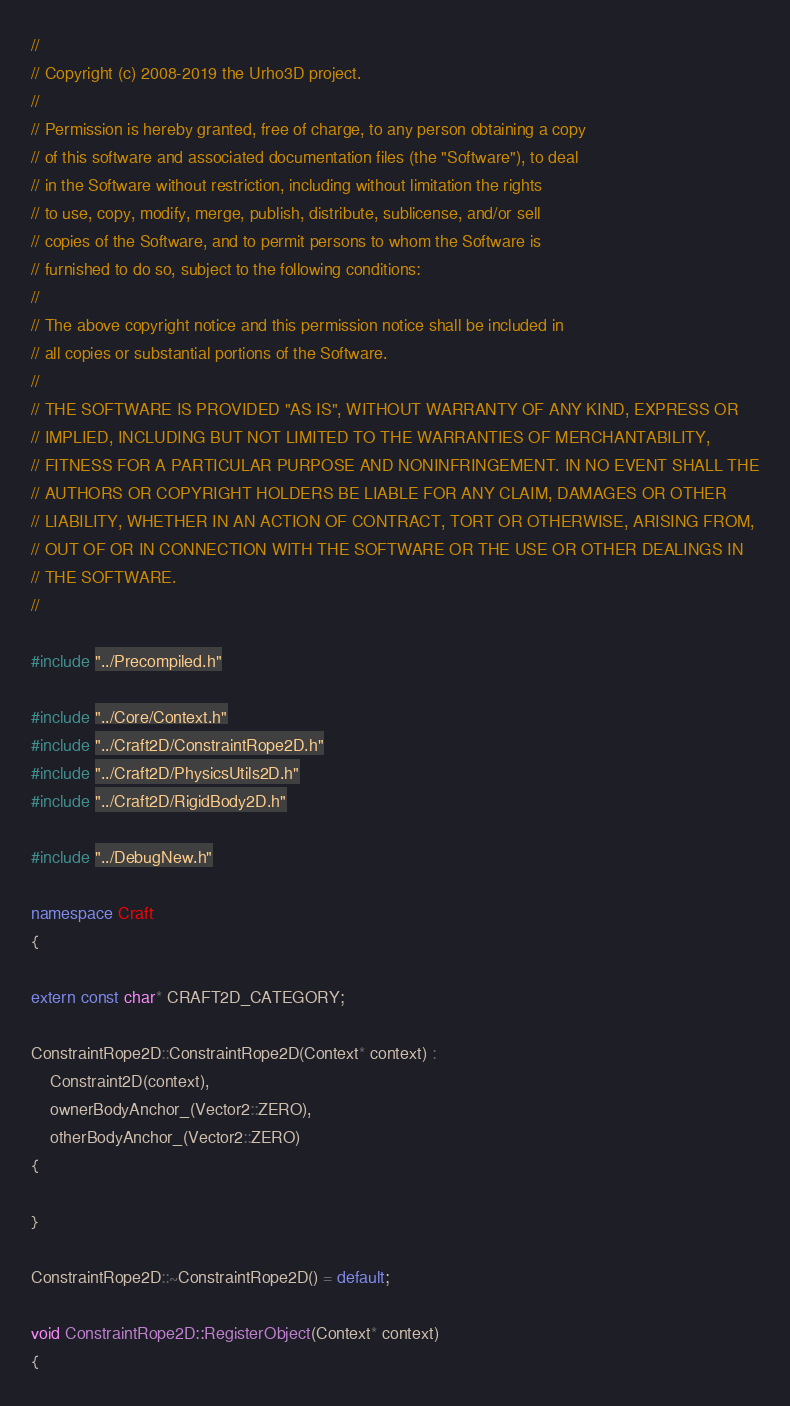<code> <loc_0><loc_0><loc_500><loc_500><_C++_>//
// Copyright (c) 2008-2019 the Urho3D project.
//
// Permission is hereby granted, free of charge, to any person obtaining a copy
// of this software and associated documentation files (the "Software"), to deal
// in the Software without restriction, including without limitation the rights
// to use, copy, modify, merge, publish, distribute, sublicense, and/or sell
// copies of the Software, and to permit persons to whom the Software is
// furnished to do so, subject to the following conditions:
//
// The above copyright notice and this permission notice shall be included in
// all copies or substantial portions of the Software.
//
// THE SOFTWARE IS PROVIDED "AS IS", WITHOUT WARRANTY OF ANY KIND, EXPRESS OR
// IMPLIED, INCLUDING BUT NOT LIMITED TO THE WARRANTIES OF MERCHANTABILITY,
// FITNESS FOR A PARTICULAR PURPOSE AND NONINFRINGEMENT. IN NO EVENT SHALL THE
// AUTHORS OR COPYRIGHT HOLDERS BE LIABLE FOR ANY CLAIM, DAMAGES OR OTHER
// LIABILITY, WHETHER IN AN ACTION OF CONTRACT, TORT OR OTHERWISE, ARISING FROM,
// OUT OF OR IN CONNECTION WITH THE SOFTWARE OR THE USE OR OTHER DEALINGS IN
// THE SOFTWARE.
//

#include "../Precompiled.h"

#include "../Core/Context.h"
#include "../Craft2D/ConstraintRope2D.h"
#include "../Craft2D/PhysicsUtils2D.h"
#include "../Craft2D/RigidBody2D.h"

#include "../DebugNew.h"

namespace Craft
{

extern const char* CRAFT2D_CATEGORY;

ConstraintRope2D::ConstraintRope2D(Context* context) :
    Constraint2D(context),
    ownerBodyAnchor_(Vector2::ZERO),
    otherBodyAnchor_(Vector2::ZERO)
{

}

ConstraintRope2D::~ConstraintRope2D() = default;

void ConstraintRope2D::RegisterObject(Context* context)
{</code> 